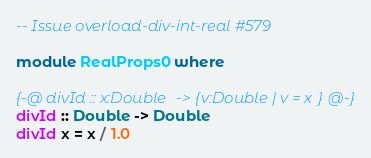<code> <loc_0><loc_0><loc_500><loc_500><_Haskell_>
-- Issue overload-div-int-real #579

module RealProps0 where

{-@ divId :: x:Double -> {v:Double | v = x} @-}
divId :: Double -> Double 
divId x = x / 1.0

</code> 